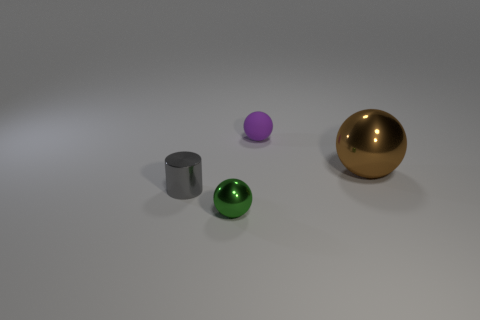Is there any other thing that has the same shape as the matte thing?
Your answer should be very brief. Yes. Do the purple sphere and the green shiny sphere have the same size?
Offer a very short reply. Yes. There is a object to the right of the tiny ball that is right of the object in front of the small gray metallic thing; what is its material?
Give a very brief answer. Metal. Are there an equal number of small green metal spheres right of the purple rubber thing and rubber objects?
Your answer should be compact. No. Are there any other things that are the same size as the cylinder?
Keep it short and to the point. Yes. What number of things are either large brown balls or brown cubes?
Your response must be concise. 1. What is the shape of the small gray object that is the same material as the big brown object?
Ensure brevity in your answer.  Cylinder. There is a thing right of the tiny sphere that is on the right side of the green thing; what is its size?
Offer a terse response. Large. What number of big objects are yellow matte blocks or brown balls?
Your answer should be compact. 1. What number of other objects are there of the same color as the tiny rubber sphere?
Your response must be concise. 0. 